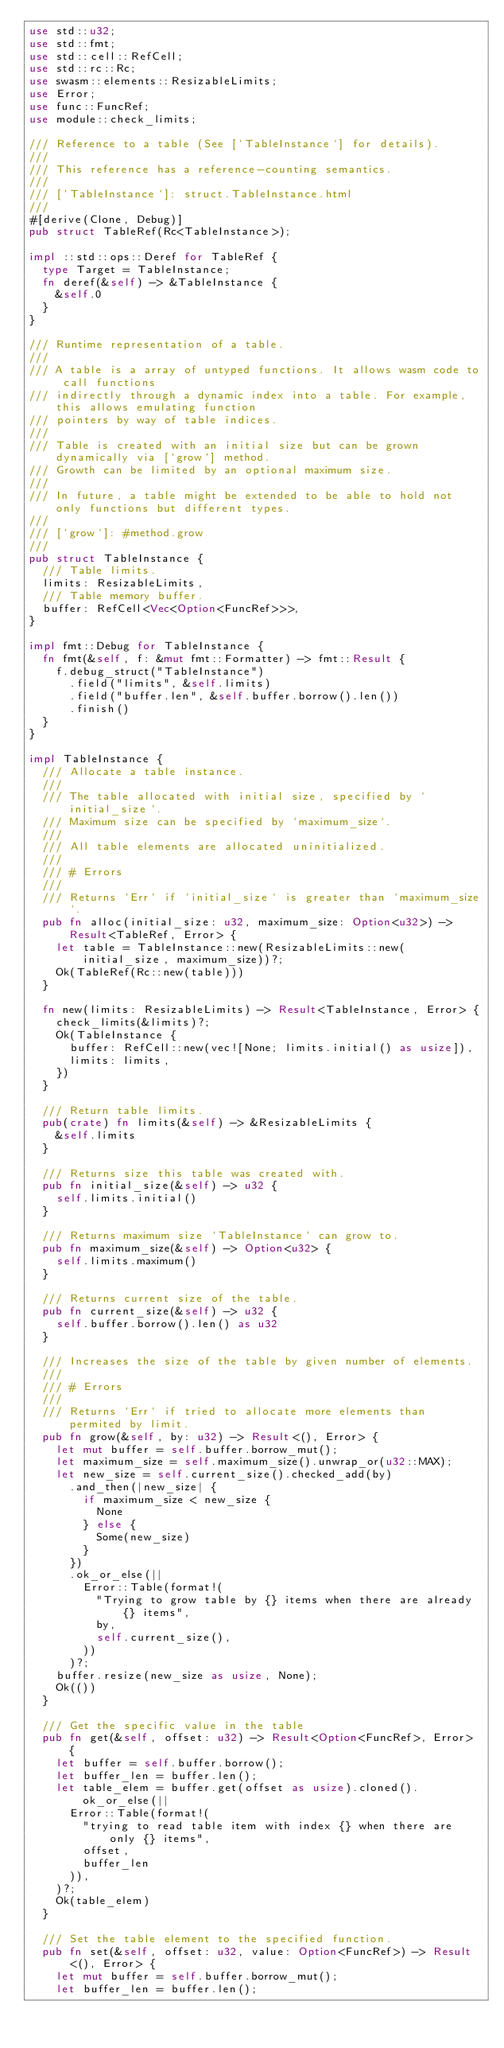<code> <loc_0><loc_0><loc_500><loc_500><_Rust_>use std::u32;
use std::fmt;
use std::cell::RefCell;
use std::rc::Rc;
use swasm::elements::ResizableLimits;
use Error;
use func::FuncRef;
use module::check_limits;

/// Reference to a table (See [`TableInstance`] for details).
///
/// This reference has a reference-counting semantics.
///
/// [`TableInstance`]: struct.TableInstance.html
///
#[derive(Clone, Debug)]
pub struct TableRef(Rc<TableInstance>);

impl ::std::ops::Deref for TableRef {
	type Target = TableInstance;
	fn deref(&self) -> &TableInstance {
		&self.0
	}
}

/// Runtime representation of a table.
///
/// A table is a array of untyped functions. It allows wasm code to call functions
/// indirectly through a dynamic index into a table. For example, this allows emulating function
/// pointers by way of table indices.
///
/// Table is created with an initial size but can be grown dynamically via [`grow`] method.
/// Growth can be limited by an optional maximum size.
///
/// In future, a table might be extended to be able to hold not only functions but different types.
///
/// [`grow`]: #method.grow
///
pub struct TableInstance {
	/// Table limits.
	limits: ResizableLimits,
	/// Table memory buffer.
	buffer: RefCell<Vec<Option<FuncRef>>>,
}

impl fmt::Debug for TableInstance {
	fn fmt(&self, f: &mut fmt::Formatter) -> fmt::Result {
		f.debug_struct("TableInstance")
			.field("limits", &self.limits)
			.field("buffer.len", &self.buffer.borrow().len())
			.finish()
	}
}

impl TableInstance {
	/// Allocate a table instance.
	///
	/// The table allocated with initial size, specified by `initial_size`.
	/// Maximum size can be specified by `maximum_size`.
	///
	/// All table elements are allocated uninitialized.
	///
	/// # Errors
	///
	/// Returns `Err` if `initial_size` is greater than `maximum_size`.
	pub fn alloc(initial_size: u32, maximum_size: Option<u32>) -> Result<TableRef, Error> {
		let table = TableInstance::new(ResizableLimits::new(initial_size, maximum_size))?;
		Ok(TableRef(Rc::new(table)))
	}

	fn new(limits: ResizableLimits) -> Result<TableInstance, Error> {
		check_limits(&limits)?;
		Ok(TableInstance {
			buffer: RefCell::new(vec![None; limits.initial() as usize]),
			limits: limits,
		})
	}

	/// Return table limits.
	pub(crate) fn limits(&self) -> &ResizableLimits {
		&self.limits
	}

	/// Returns size this table was created with.
	pub fn initial_size(&self) -> u32 {
		self.limits.initial()
	}

	/// Returns maximum size `TableInstance` can grow to.
	pub fn maximum_size(&self) -> Option<u32> {
		self.limits.maximum()
	}

	/// Returns current size of the table.
	pub fn current_size(&self) -> u32 {
		self.buffer.borrow().len() as u32
	}

	/// Increases the size of the table by given number of elements.
	///
	/// # Errors
	///
	/// Returns `Err` if tried to allocate more elements than permited by limit.
	pub fn grow(&self, by: u32) -> Result<(), Error> {
		let mut buffer = self.buffer.borrow_mut();
		let maximum_size = self.maximum_size().unwrap_or(u32::MAX);
		let new_size = self.current_size().checked_add(by)
			.and_then(|new_size| {
				if maximum_size < new_size {
					None
				} else {
					Some(new_size)
				}
			})
			.ok_or_else(||
				Error::Table(format!(
					"Trying to grow table by {} items when there are already {} items",
					by,
					self.current_size(),
				))
			)?;
		buffer.resize(new_size as usize, None);
		Ok(())
	}

	/// Get the specific value in the table
	pub fn get(&self, offset: u32) -> Result<Option<FuncRef>, Error> {
		let buffer = self.buffer.borrow();
		let buffer_len = buffer.len();
		let table_elem = buffer.get(offset as usize).cloned().ok_or_else(||
			Error::Table(format!(
				"trying to read table item with index {} when there are only {} items",
				offset,
				buffer_len
			)),
		)?;
		Ok(table_elem)
	}

	/// Set the table element to the specified function.
	pub fn set(&self, offset: u32, value: Option<FuncRef>) -> Result<(), Error> {
		let mut buffer = self.buffer.borrow_mut();
		let buffer_len = buffer.len();</code> 